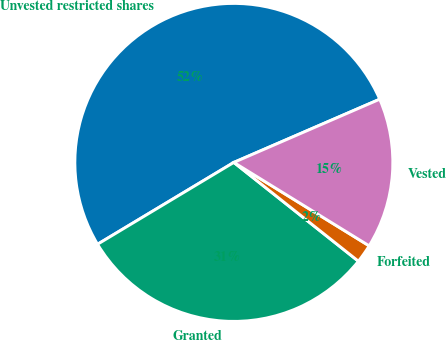<chart> <loc_0><loc_0><loc_500><loc_500><pie_chart><fcel>Unvested restricted shares<fcel>Granted<fcel>Forfeited<fcel>Vested<nl><fcel>52.1%<fcel>30.72%<fcel>1.88%<fcel>15.3%<nl></chart> 